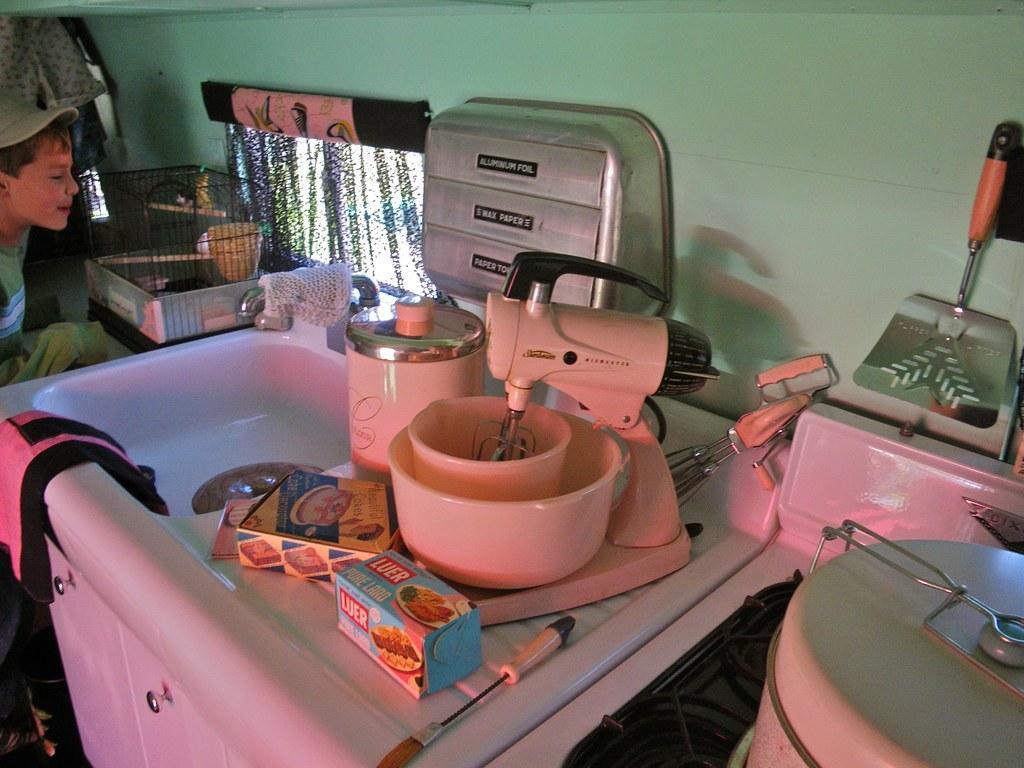Describe this image in one or two sentences. In this picture there are kitchenware on the right on the right side of the image and there is a boy and a cage on the left side of the image, there is a sink on the left side of the image. 